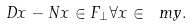<formula> <loc_0><loc_0><loc_500><loc_500>D x - N x \in F _ { \bot } \forall x \in \ m y .</formula> 